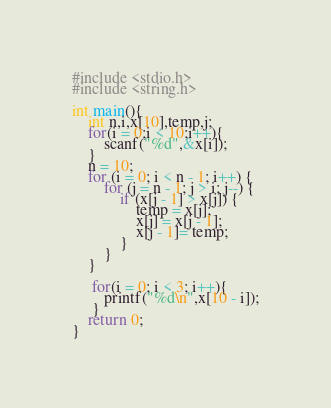Convert code to text. <code><loc_0><loc_0><loc_500><loc_500><_C_>#include <stdio.h>
#include <string.h>

int main(){
	int n,i,x[10],temp,j;
	for(i = 0;i < 10;i++){
		scanf("%d",&x[i]);
	}
	n = 10;
    for (i = 0; i < n - 1; i++) {
        for (j = n - 1; j > i; j--) {
            if (x[j - 1] > x[j]) {  
                temp = x[j];        
                x[j] = x[j - 1];
                x[j - 1]= temp;
            }
        }	
    }
    
     for(i = 0; i < 3; i++){
    	printf("%d\n",x[10 - i]);
     }
	return 0;
}</code> 